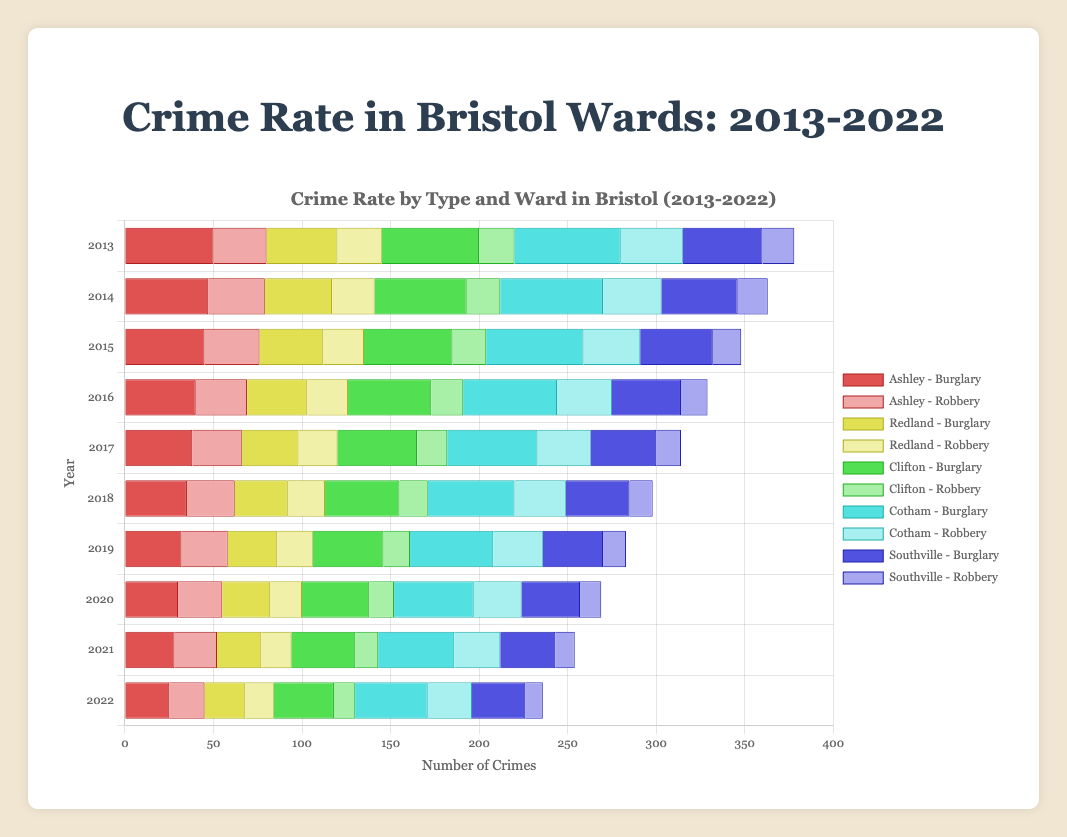What is the trend of burglary crimes in the Ashley ward from 2013 to 2022? Observing the horizontal bars for burglary in Ashley, they decrease progressively from 50 in 2013 to 25 in 2022.
Answer: Decreasing Which ward experienced the highest number of burglaries in 2022? Comparing the length of burglary bars for all wards in 2022, Cotham has the longest bar indicating 41 cases.
Answer: Cotham Between Redland and Southville, which ward saw a greater reduction in robbery cases from 2013 to 2022? Robbery cases in Redland decreased from 25 to 16 (a decrease of 9), while in Southville it decreased from 18 to 10 (a decrease of 8).
Answer: Redland What is the average number of robberies in Clifton over the decade? Summing up robberies in Clifton from 2013 to 2022 gives 159. Dividing by 10 years, the average is 159/10.
Answer: 15.9 Which crime type saw more reduction in Cotham ward: burglary or robbery from 2013 to 2022? Burglary in Cotham decreased from 60 to 41 (a decrease of 19), while robbery decreased from 35 to 25 (a decrease of 10).
Answer: Burglary What is the difference in the number of burglaries between 2013 and 2022 in Southville? Subtracting 2022 burglaries (30) from 2013 burglaries (45) in Southville.
Answer: 15 How does the number of burglaries in Redland in 2015 compare with the number of robberies in Ashley in the same year? Comparing burglary in Redland (36) and robbery in Ashley (31) for 2015.
Answer: Redland has more What is the combined total of robbery cases in 2020 for all the wards? Summing up the 2020 robbery cases for Ashley (25), Redland (18), Clifton (14), Cotham (27), and Southville (12). The total is 25 + 18 + 14 + 27 + 12.
Answer: 96 Which ward had the least number of robbery cases in 2022, and how many were there? Observing the shortest robbery bar in 2022, Southville had the least with 10 cases.
Answer: Southville, 10 Which ward showed the smallest decrease in burglary cases from 2013 to 2022? Calculating the decrease for burglary in each ward: Ashley (25), Redland (17), Clifton (21), Cotham (19), Southville (15). Southville has the smallest decrease.
Answer: Southville 